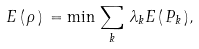Convert formula to latex. <formula><loc_0><loc_0><loc_500><loc_500>E \, ( \, \rho \, ) \, = \min \, \sum _ { k } \, \lambda _ { k } E \, ( \, P _ { k } \, ) ,</formula> 